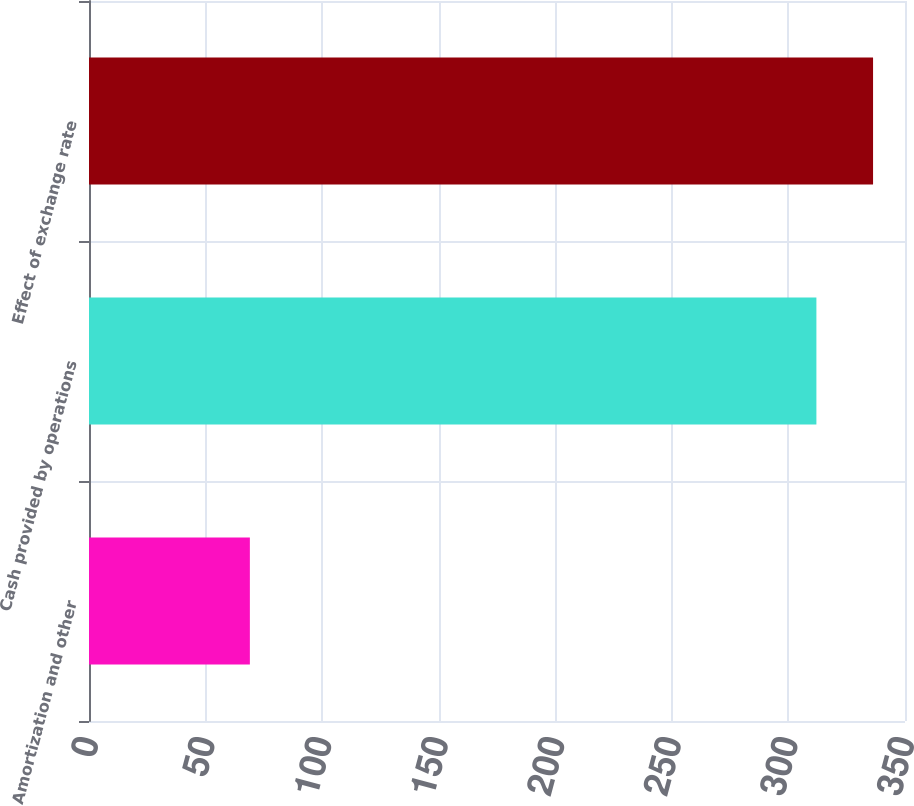Convert chart. <chart><loc_0><loc_0><loc_500><loc_500><bar_chart><fcel>Amortization and other<fcel>Cash provided by operations<fcel>Effect of exchange rate<nl><fcel>69<fcel>312<fcel>336.3<nl></chart> 